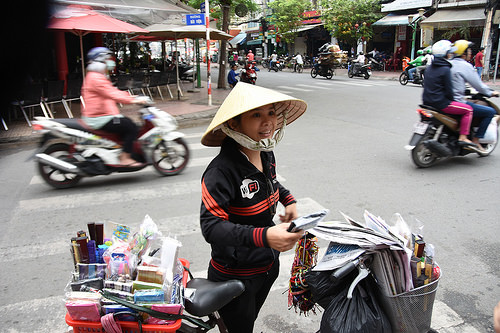<image>
Is there a papers in the basket? Yes. The papers is contained within or inside the basket, showing a containment relationship. Where is the basket in relation to the seat? Is it in front of the seat? Yes. The basket is positioned in front of the seat, appearing closer to the camera viewpoint. 